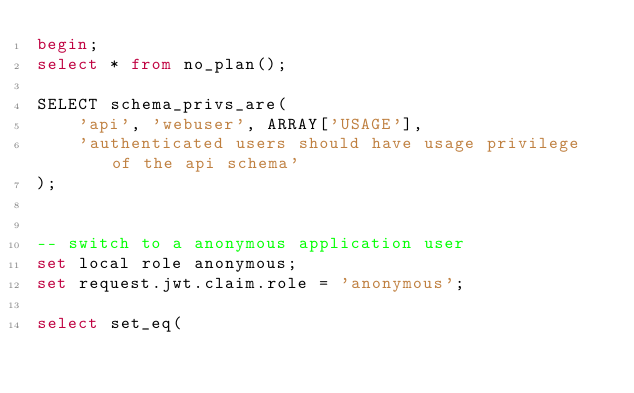<code> <loc_0><loc_0><loc_500><loc_500><_SQL_>begin;
select * from no_plan();

SELECT schema_privs_are(
    'api', 'webuser', ARRAY['USAGE'],
    'authenticated users should have usage privilege of the api schema'
);


-- switch to a anonymous application user
set local role anonymous;
set request.jwt.claim.role = 'anonymous';

select set_eq(</code> 